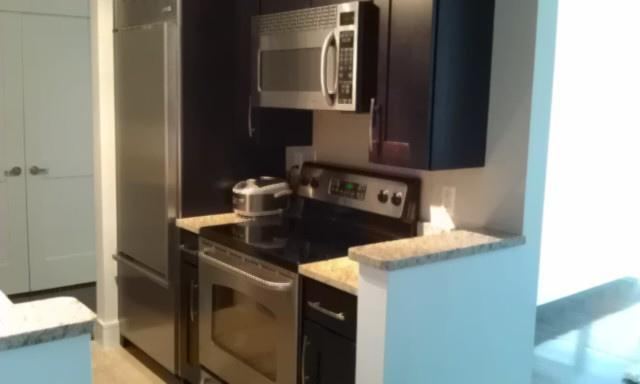What are the appliances made of? Please explain your reasoning. steel. The appliances are silver and shiny. 